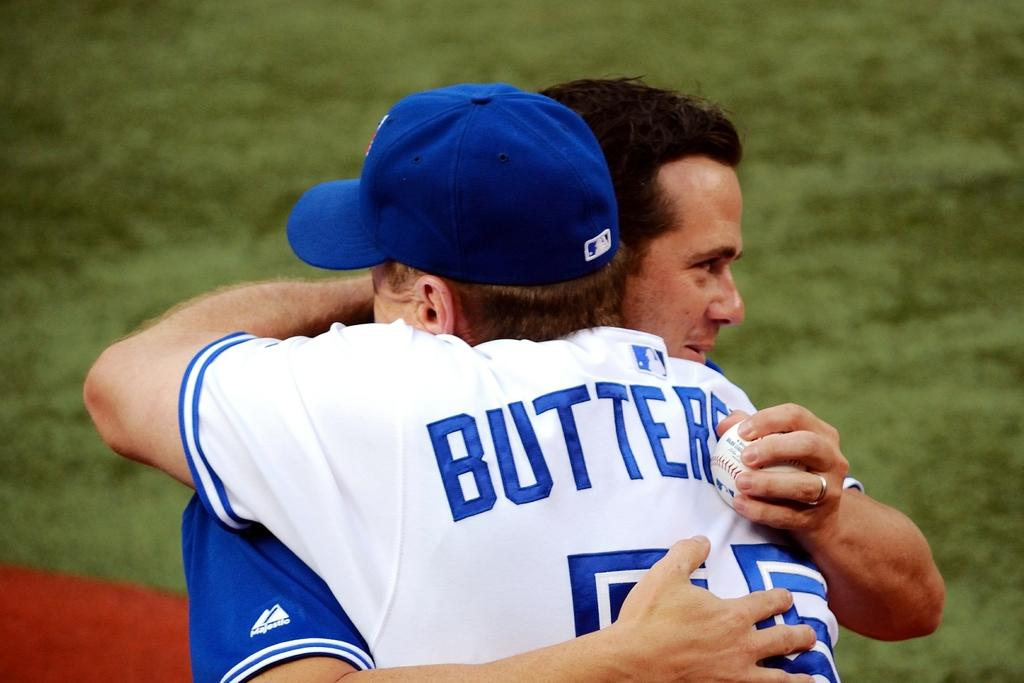How many people are in the image? There are two persons in the image. What is one person wearing? One person is wearing a cap. What is the other person holding? The other person is holding a ball in his hand. What type of surface is visible in the background of the image? There is grass visible in the background of the image. What type of frame is visible around the image? There is no frame visible around the image, as the image is not presented within a frame. What sport is being played in the image? The image does not depict a sport being played, as there is no indication of a specific sport or activity involving the ball. 